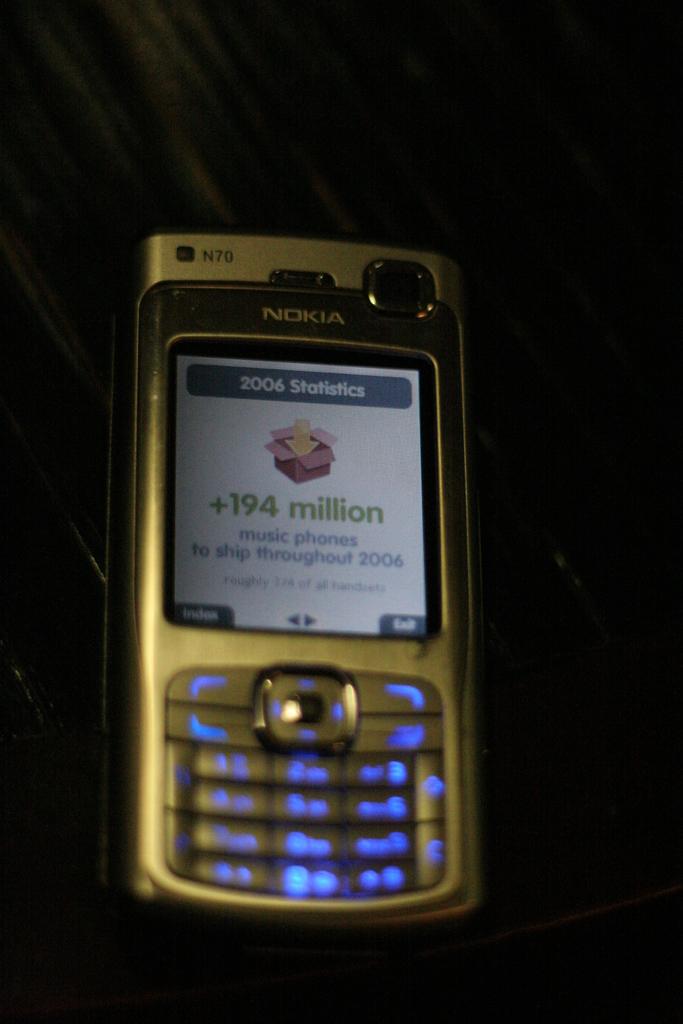What model is this nokia phone?
Give a very brief answer. N70. How many millions is displayed on the screen?
Offer a terse response. 194. 